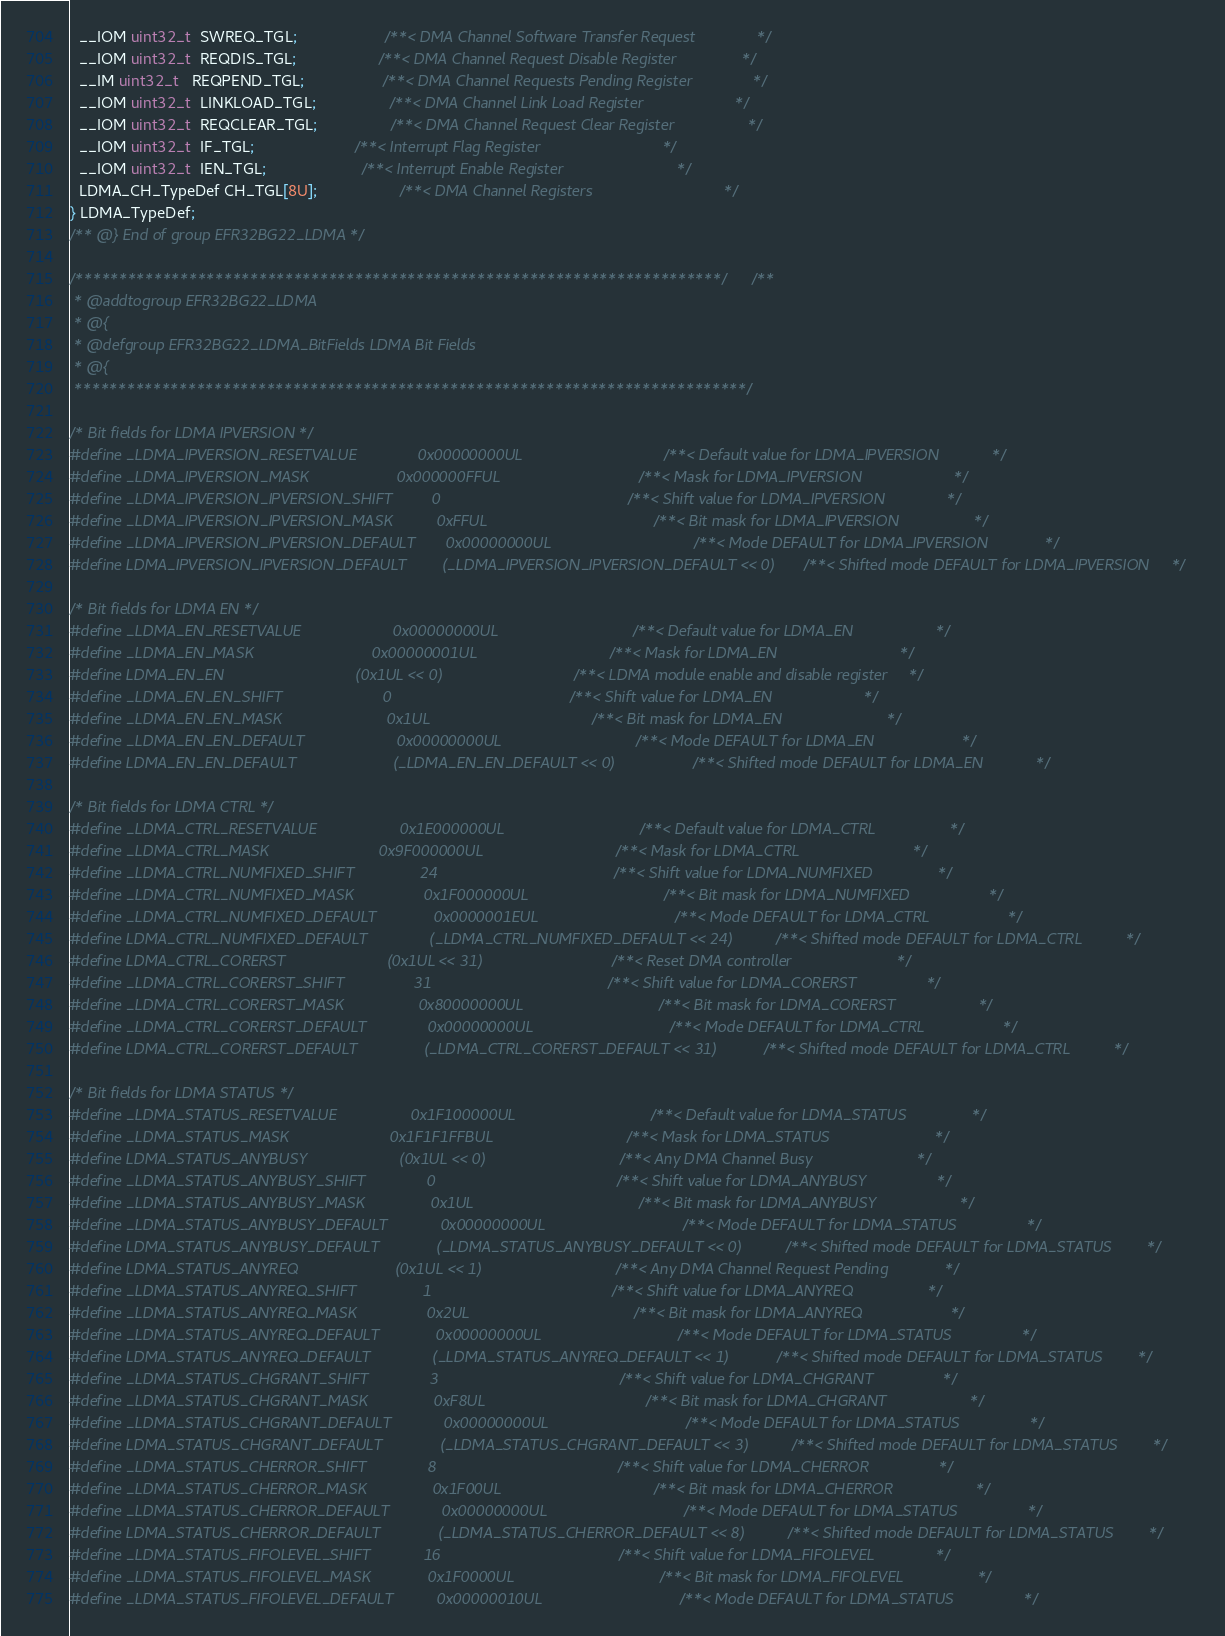<code> <loc_0><loc_0><loc_500><loc_500><_C_>  __IOM uint32_t  SWREQ_TGL;                    /**< DMA Channel Software Transfer Request              */
  __IOM uint32_t  REQDIS_TGL;                   /**< DMA Channel Request Disable Register               */
  __IM uint32_t   REQPEND_TGL;                  /**< DMA Channel Requests Pending Register              */
  __IOM uint32_t  LINKLOAD_TGL;                 /**< DMA Channel Link Load Register                     */
  __IOM uint32_t  REQCLEAR_TGL;                 /**< DMA Channel Request Clear Register                 */
  __IOM uint32_t  IF_TGL;                       /**< Interrupt Flag Register                            */
  __IOM uint32_t  IEN_TGL;                      /**< Interrupt Enable Register                          */
  LDMA_CH_TypeDef CH_TGL[8U];                   /**< DMA Channel Registers                              */
} LDMA_TypeDef;
/** @} End of group EFR32BG22_LDMA */

/**************************************************************************//**
 * @addtogroup EFR32BG22_LDMA
 * @{
 * @defgroup EFR32BG22_LDMA_BitFields LDMA Bit Fields
 * @{
 *****************************************************************************/

/* Bit fields for LDMA IPVERSION */
#define _LDMA_IPVERSION_RESETVALUE              0x00000000UL                             /**< Default value for LDMA_IPVERSION            */
#define _LDMA_IPVERSION_MASK                    0x000000FFUL                             /**< Mask for LDMA_IPVERSION                     */
#define _LDMA_IPVERSION_IPVERSION_SHIFT         0                                        /**< Shift value for LDMA_IPVERSION              */
#define _LDMA_IPVERSION_IPVERSION_MASK          0xFFUL                                   /**< Bit mask for LDMA_IPVERSION                 */
#define _LDMA_IPVERSION_IPVERSION_DEFAULT       0x00000000UL                             /**< Mode DEFAULT for LDMA_IPVERSION             */
#define LDMA_IPVERSION_IPVERSION_DEFAULT        (_LDMA_IPVERSION_IPVERSION_DEFAULT << 0) /**< Shifted mode DEFAULT for LDMA_IPVERSION     */

/* Bit fields for LDMA EN */
#define _LDMA_EN_RESETVALUE                     0x00000000UL                            /**< Default value for LDMA_EN                   */
#define _LDMA_EN_MASK                           0x00000001UL                            /**< Mask for LDMA_EN                            */
#define LDMA_EN_EN                              (0x1UL << 0)                            /**< LDMA module enable and disable register     */
#define _LDMA_EN_EN_SHIFT                       0                                       /**< Shift value for LDMA_EN                     */
#define _LDMA_EN_EN_MASK                        0x1UL                                   /**< Bit mask for LDMA_EN                        */
#define _LDMA_EN_EN_DEFAULT                     0x00000000UL                            /**< Mode DEFAULT for LDMA_EN                    */
#define LDMA_EN_EN_DEFAULT                      (_LDMA_EN_EN_DEFAULT << 0)              /**< Shifted mode DEFAULT for LDMA_EN            */

/* Bit fields for LDMA CTRL */
#define _LDMA_CTRL_RESETVALUE                   0x1E000000UL                            /**< Default value for LDMA_CTRL                 */
#define _LDMA_CTRL_MASK                         0x9F000000UL                            /**< Mask for LDMA_CTRL                          */
#define _LDMA_CTRL_NUMFIXED_SHIFT               24                                      /**< Shift value for LDMA_NUMFIXED               */
#define _LDMA_CTRL_NUMFIXED_MASK                0x1F000000UL                            /**< Bit mask for LDMA_NUMFIXED                  */
#define _LDMA_CTRL_NUMFIXED_DEFAULT             0x0000001EUL                            /**< Mode DEFAULT for LDMA_CTRL                  */
#define LDMA_CTRL_NUMFIXED_DEFAULT              (_LDMA_CTRL_NUMFIXED_DEFAULT << 24)     /**< Shifted mode DEFAULT for LDMA_CTRL          */
#define LDMA_CTRL_CORERST                       (0x1UL << 31)                           /**< Reset DMA controller                        */
#define _LDMA_CTRL_CORERST_SHIFT                31                                      /**< Shift value for LDMA_CORERST                */
#define _LDMA_CTRL_CORERST_MASK                 0x80000000UL                            /**< Bit mask for LDMA_CORERST                   */
#define _LDMA_CTRL_CORERST_DEFAULT              0x00000000UL                            /**< Mode DEFAULT for LDMA_CTRL                  */
#define LDMA_CTRL_CORERST_DEFAULT               (_LDMA_CTRL_CORERST_DEFAULT << 31)      /**< Shifted mode DEFAULT for LDMA_CTRL          */

/* Bit fields for LDMA STATUS */
#define _LDMA_STATUS_RESETVALUE                 0x1F100000UL                            /**< Default value for LDMA_STATUS               */
#define _LDMA_STATUS_MASK                       0x1F1F1FFBUL                            /**< Mask for LDMA_STATUS                        */
#define LDMA_STATUS_ANYBUSY                     (0x1UL << 0)                            /**< Any DMA Channel Busy                        */
#define _LDMA_STATUS_ANYBUSY_SHIFT              0                                       /**< Shift value for LDMA_ANYBUSY                */
#define _LDMA_STATUS_ANYBUSY_MASK               0x1UL                                   /**< Bit mask for LDMA_ANYBUSY                   */
#define _LDMA_STATUS_ANYBUSY_DEFAULT            0x00000000UL                            /**< Mode DEFAULT for LDMA_STATUS                */
#define LDMA_STATUS_ANYBUSY_DEFAULT             (_LDMA_STATUS_ANYBUSY_DEFAULT << 0)     /**< Shifted mode DEFAULT for LDMA_STATUS        */
#define LDMA_STATUS_ANYREQ                      (0x1UL << 1)                            /**< Any DMA Channel Request Pending             */
#define _LDMA_STATUS_ANYREQ_SHIFT               1                                       /**< Shift value for LDMA_ANYREQ                 */
#define _LDMA_STATUS_ANYREQ_MASK                0x2UL                                   /**< Bit mask for LDMA_ANYREQ                    */
#define _LDMA_STATUS_ANYREQ_DEFAULT             0x00000000UL                            /**< Mode DEFAULT for LDMA_STATUS                */
#define LDMA_STATUS_ANYREQ_DEFAULT              (_LDMA_STATUS_ANYREQ_DEFAULT << 1)      /**< Shifted mode DEFAULT for LDMA_STATUS        */
#define _LDMA_STATUS_CHGRANT_SHIFT              3                                       /**< Shift value for LDMA_CHGRANT                */
#define _LDMA_STATUS_CHGRANT_MASK               0xF8UL                                  /**< Bit mask for LDMA_CHGRANT                   */
#define _LDMA_STATUS_CHGRANT_DEFAULT            0x00000000UL                            /**< Mode DEFAULT for LDMA_STATUS                */
#define LDMA_STATUS_CHGRANT_DEFAULT             (_LDMA_STATUS_CHGRANT_DEFAULT << 3)     /**< Shifted mode DEFAULT for LDMA_STATUS        */
#define _LDMA_STATUS_CHERROR_SHIFT              8                                       /**< Shift value for LDMA_CHERROR                */
#define _LDMA_STATUS_CHERROR_MASK               0x1F00UL                                /**< Bit mask for LDMA_CHERROR                   */
#define _LDMA_STATUS_CHERROR_DEFAULT            0x00000000UL                            /**< Mode DEFAULT for LDMA_STATUS                */
#define LDMA_STATUS_CHERROR_DEFAULT             (_LDMA_STATUS_CHERROR_DEFAULT << 8)     /**< Shifted mode DEFAULT for LDMA_STATUS        */
#define _LDMA_STATUS_FIFOLEVEL_SHIFT            16                                      /**< Shift value for LDMA_FIFOLEVEL              */
#define _LDMA_STATUS_FIFOLEVEL_MASK             0x1F0000UL                              /**< Bit mask for LDMA_FIFOLEVEL                 */
#define _LDMA_STATUS_FIFOLEVEL_DEFAULT          0x00000010UL                            /**< Mode DEFAULT for LDMA_STATUS                */</code> 